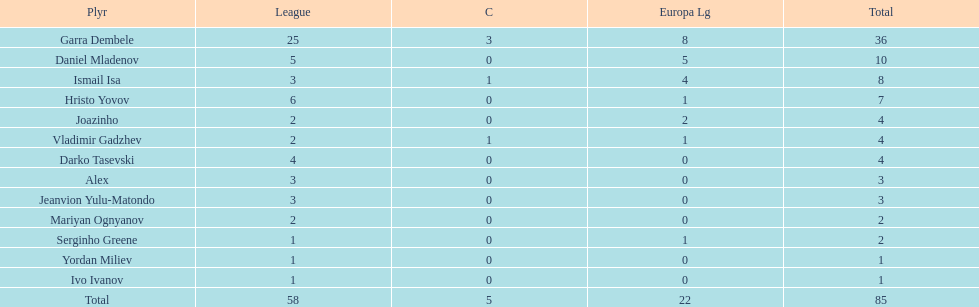How many goals did ismail isa score this season? 8. 